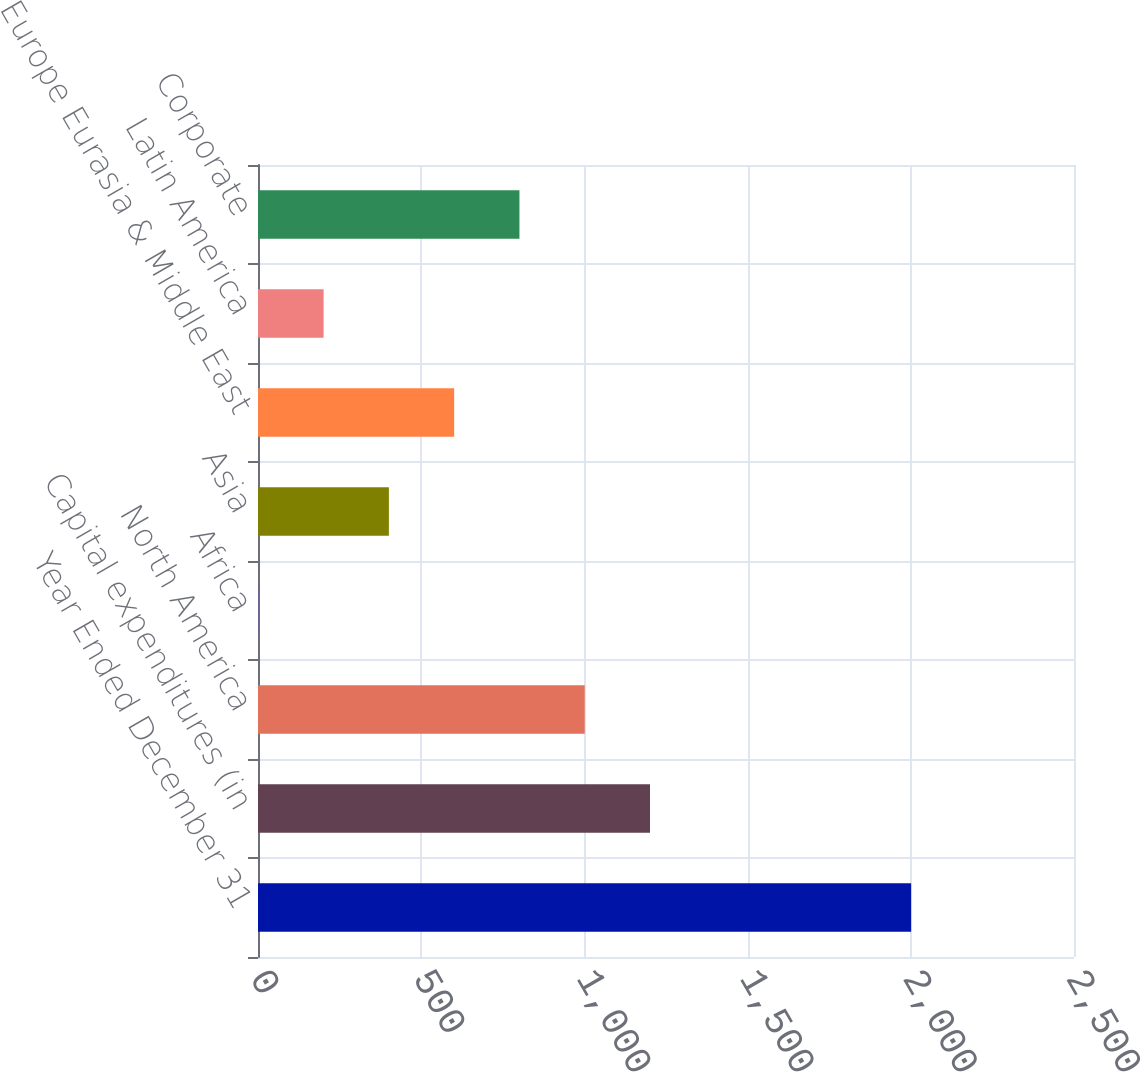<chart> <loc_0><loc_0><loc_500><loc_500><bar_chart><fcel>Year Ended December 31<fcel>Capital expenditures (in<fcel>North America<fcel>Africa<fcel>Asia<fcel>Europe Eurasia & Middle East<fcel>Latin America<fcel>Corporate<nl><fcel>2001<fcel>1201<fcel>1001<fcel>1<fcel>401<fcel>601<fcel>201<fcel>801<nl></chart> 